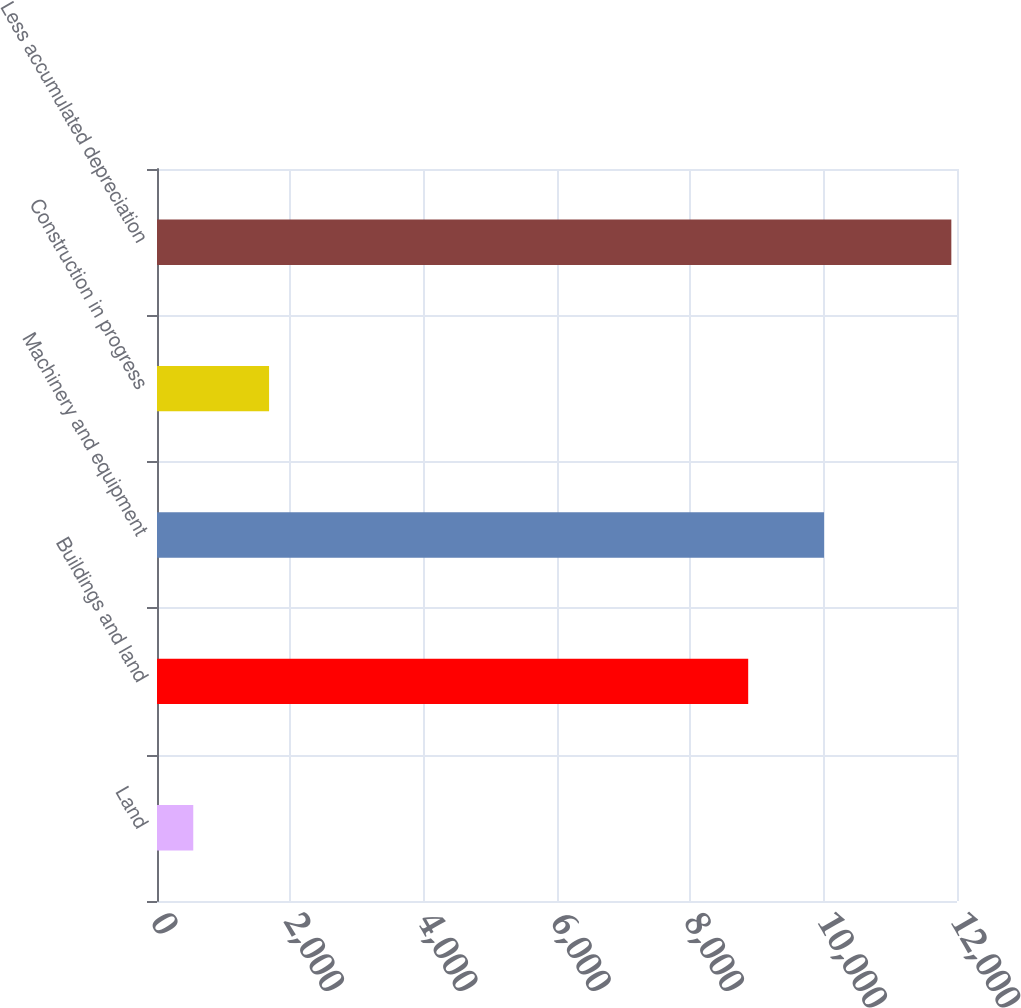Convert chart. <chart><loc_0><loc_0><loc_500><loc_500><bar_chart><fcel>Land<fcel>Buildings and land<fcel>Machinery and equipment<fcel>Construction in progress<fcel>Less accumulated depreciation<nl><fcel>544<fcel>8868<fcel>10005.1<fcel>1681.1<fcel>11915<nl></chart> 